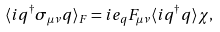<formula> <loc_0><loc_0><loc_500><loc_500>\langle { i q } ^ { \dagger } \sigma _ { \mu \nu } q \rangle _ { F } = i e _ { q } { F _ { \mu \nu } } \langle { i q } ^ { \dagger } q \rangle \chi ,</formula> 